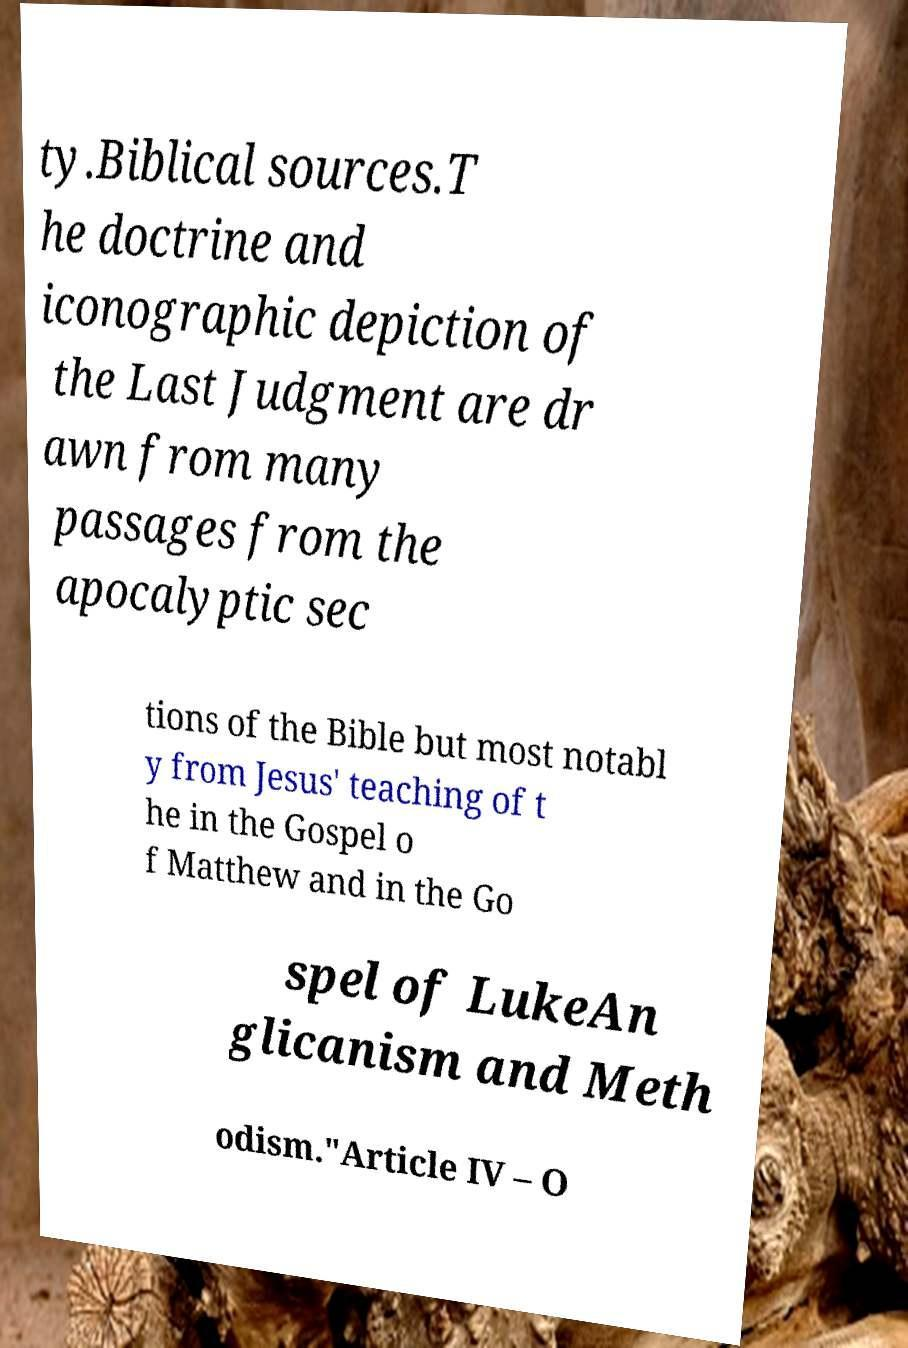Could you extract and type out the text from this image? ty.Biblical sources.T he doctrine and iconographic depiction of the Last Judgment are dr awn from many passages from the apocalyptic sec tions of the Bible but most notabl y from Jesus' teaching of t he in the Gospel o f Matthew and in the Go spel of LukeAn glicanism and Meth odism."Article IV – O 